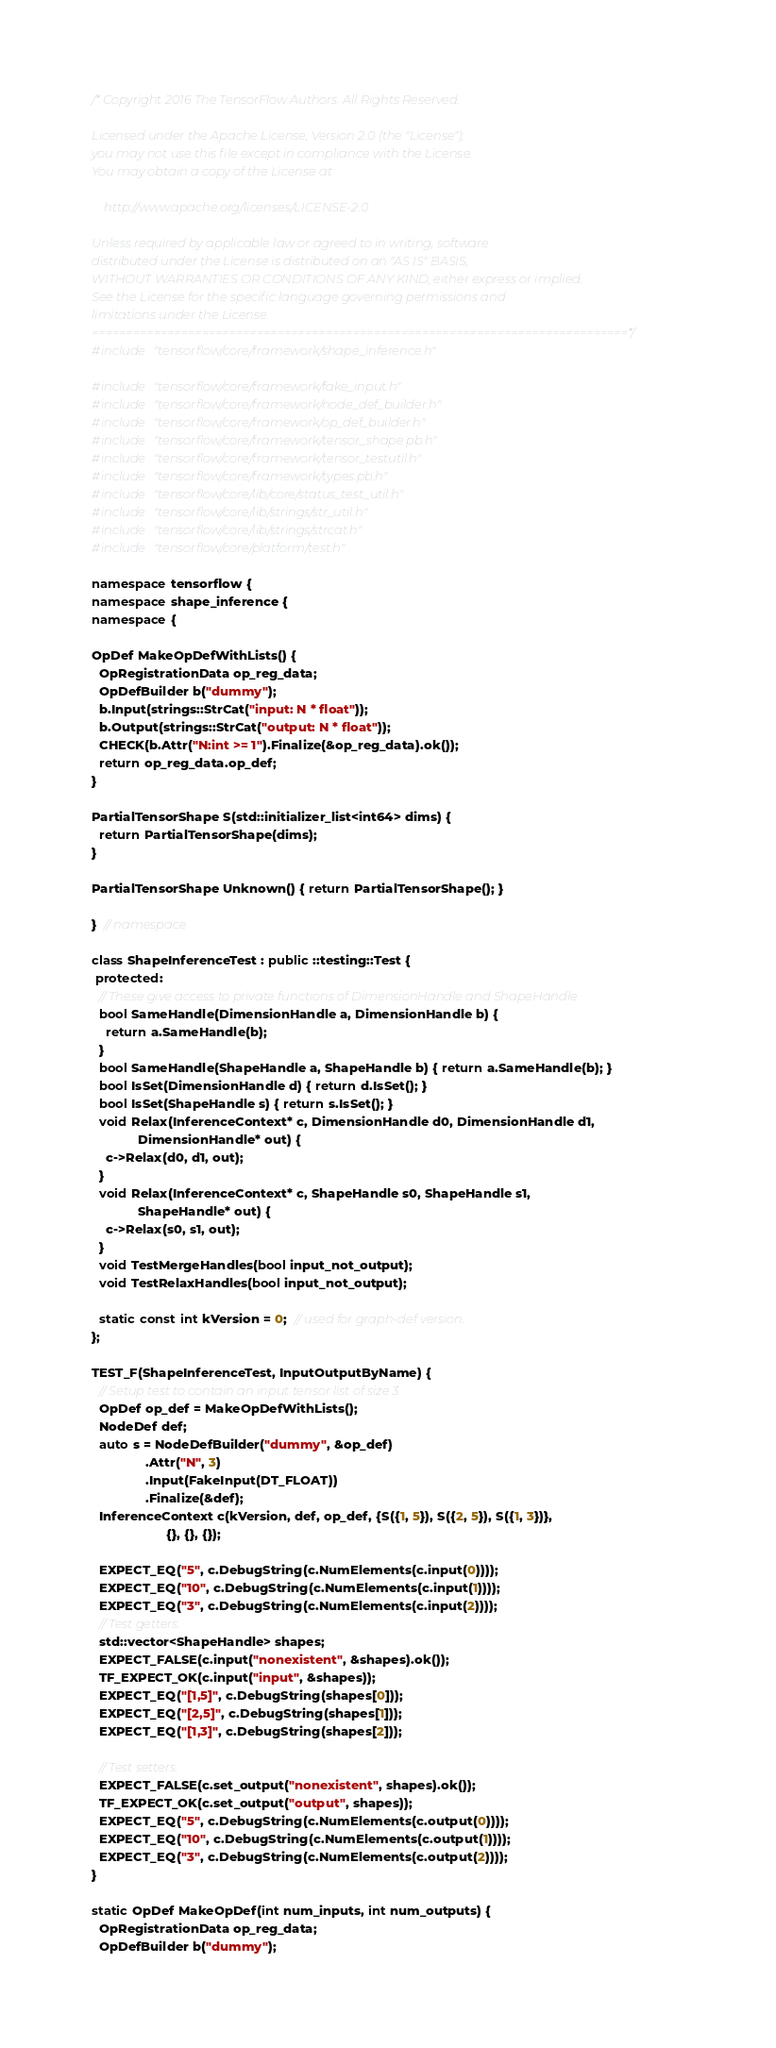Convert code to text. <code><loc_0><loc_0><loc_500><loc_500><_C++_>/* Copyright 2016 The TensorFlow Authors. All Rights Reserved.

Licensed under the Apache License, Version 2.0 (the "License");
you may not use this file except in compliance with the License.
You may obtain a copy of the License at

    http://www.apache.org/licenses/LICENSE-2.0

Unless required by applicable law or agreed to in writing, software
distributed under the License is distributed on an "AS IS" BASIS,
WITHOUT WARRANTIES OR CONDITIONS OF ANY KIND, either express or implied.
See the License for the specific language governing permissions and
limitations under the License.
==============================================================================*/
#include "tensorflow/core/framework/shape_inference.h"

#include "tensorflow/core/framework/fake_input.h"
#include "tensorflow/core/framework/node_def_builder.h"
#include "tensorflow/core/framework/op_def_builder.h"
#include "tensorflow/core/framework/tensor_shape.pb.h"
#include "tensorflow/core/framework/tensor_testutil.h"
#include "tensorflow/core/framework/types.pb.h"
#include "tensorflow/core/lib/core/status_test_util.h"
#include "tensorflow/core/lib/strings/str_util.h"
#include "tensorflow/core/lib/strings/strcat.h"
#include "tensorflow/core/platform/test.h"

namespace tensorflow {
namespace shape_inference {
namespace {

OpDef MakeOpDefWithLists() {
  OpRegistrationData op_reg_data;
  OpDefBuilder b("dummy");
  b.Input(strings::StrCat("input: N * float"));
  b.Output(strings::StrCat("output: N * float"));
  CHECK(b.Attr("N:int >= 1").Finalize(&op_reg_data).ok());
  return op_reg_data.op_def;
}

PartialTensorShape S(std::initializer_list<int64> dims) {
  return PartialTensorShape(dims);
}

PartialTensorShape Unknown() { return PartialTensorShape(); }

}  // namespace

class ShapeInferenceTest : public ::testing::Test {
 protected:
  // These give access to private functions of DimensionHandle and ShapeHandle.
  bool SameHandle(DimensionHandle a, DimensionHandle b) {
    return a.SameHandle(b);
  }
  bool SameHandle(ShapeHandle a, ShapeHandle b) { return a.SameHandle(b); }
  bool IsSet(DimensionHandle d) { return d.IsSet(); }
  bool IsSet(ShapeHandle s) { return s.IsSet(); }
  void Relax(InferenceContext* c, DimensionHandle d0, DimensionHandle d1,
             DimensionHandle* out) {
    c->Relax(d0, d1, out);
  }
  void Relax(InferenceContext* c, ShapeHandle s0, ShapeHandle s1,
             ShapeHandle* out) {
    c->Relax(s0, s1, out);
  }
  void TestMergeHandles(bool input_not_output);
  void TestRelaxHandles(bool input_not_output);

  static const int kVersion = 0;  // used for graph-def version.
};

TEST_F(ShapeInferenceTest, InputOutputByName) {
  // Setup test to contain an input tensor list of size 3.
  OpDef op_def = MakeOpDefWithLists();
  NodeDef def;
  auto s = NodeDefBuilder("dummy", &op_def)
               .Attr("N", 3)
               .Input(FakeInput(DT_FLOAT))
               .Finalize(&def);
  InferenceContext c(kVersion, def, op_def, {S({1, 5}), S({2, 5}), S({1, 3})},
                     {}, {}, {});

  EXPECT_EQ("5", c.DebugString(c.NumElements(c.input(0))));
  EXPECT_EQ("10", c.DebugString(c.NumElements(c.input(1))));
  EXPECT_EQ("3", c.DebugString(c.NumElements(c.input(2))));
  // Test getters.
  std::vector<ShapeHandle> shapes;
  EXPECT_FALSE(c.input("nonexistent", &shapes).ok());
  TF_EXPECT_OK(c.input("input", &shapes));
  EXPECT_EQ("[1,5]", c.DebugString(shapes[0]));
  EXPECT_EQ("[2,5]", c.DebugString(shapes[1]));
  EXPECT_EQ("[1,3]", c.DebugString(shapes[2]));

  // Test setters.
  EXPECT_FALSE(c.set_output("nonexistent", shapes).ok());
  TF_EXPECT_OK(c.set_output("output", shapes));
  EXPECT_EQ("5", c.DebugString(c.NumElements(c.output(0))));
  EXPECT_EQ("10", c.DebugString(c.NumElements(c.output(1))));
  EXPECT_EQ("3", c.DebugString(c.NumElements(c.output(2))));
}

static OpDef MakeOpDef(int num_inputs, int num_outputs) {
  OpRegistrationData op_reg_data;
  OpDefBuilder b("dummy");</code> 